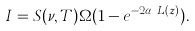Convert formula to latex. <formula><loc_0><loc_0><loc_500><loc_500>I = S ( \nu , T ) \Omega ( 1 - e ^ { - 2 \alpha _ { S } L ( z ) } ) .</formula> 